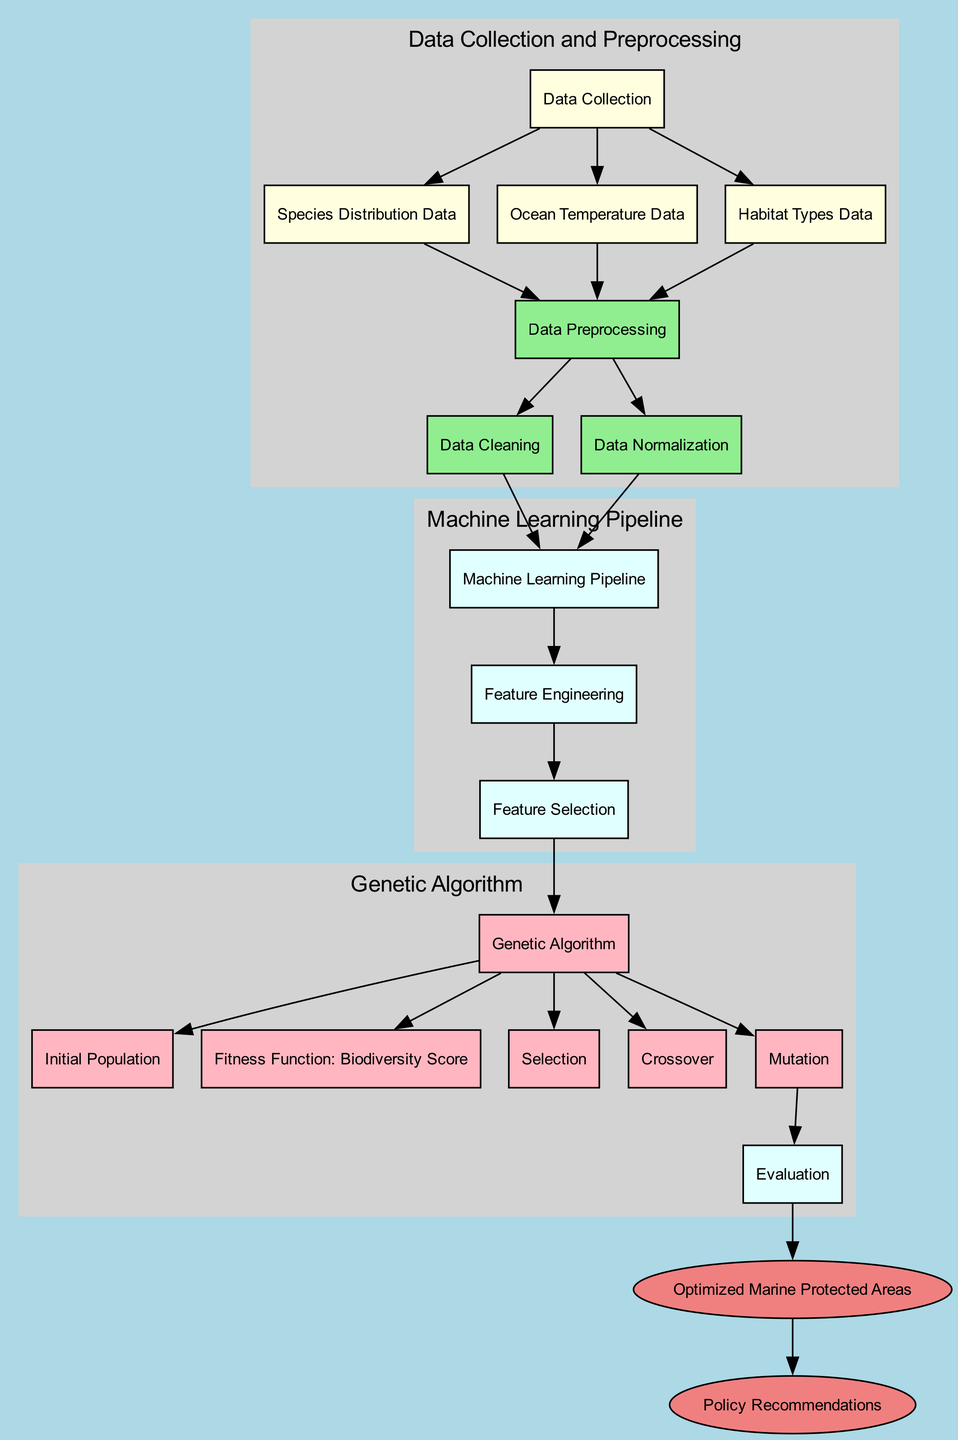What is the starting point of the diagram? The starting point of the diagram is the node labeled "Data Collection". It serves as the first step before any data processing occurs.
Answer: Data Collection How many nodes are in the diagram? The diagram contains a total of 17 nodes, each representing a different component of the marine protected areas optimization process.
Answer: 17 Which node follows the "Data Preprocessing" node? The nodes that immediately follow "Data Preprocessing" are "Cleaning" and "Normalization". Both of these processes depend on the output of data preprocessing.
Answer: Cleaning and Normalization What is the role of the "Fitness Function" node? The "Fitness Function" node is crucial in the genetic algorithm process as it evaluates the biodiversity score, guiding the optimization of marine protected areas.
Answer: Evaluate biodiversity score Which nodes are included in the genetic algorithm process? The nodes included in the genetic algorithm process are "Genetic Algorithm", "Initial Population", "Fitness Function", "Selection", "Crossover", "Mutation", and "Evaluation", making it the most complex segment of the diagram.
Answer: Genetic Algorithm, Initial Population, Fitness Function, Selection, Crossover, Mutation, Evaluation What is the endpoint of the process shown in the diagram? The endpoint of the process is the node labeled "Policy Recommendations", which relies on the results from the "Optimized Marine Protected Areas".
Answer: Policy Recommendations How does "Ocean Temperature Data" relate to "Data Preprocessing"? The "Ocean Temperature Data" feeds into the "Data Preprocessing" node, signifying that it is one of the initial data types that will undergo cleaning, normalization, and further analysis.
Answer: Feeds into Data Preprocessing What action follows the "Evaluation" node in the diagram? After the "Evaluation" node, the action that follows is the output of the "Optimized Marine Protected Areas", guiding the decision-making process in conservation strategies.
Answer: Optimized Marine Protected Areas Which subgraph does "Feature Selection" belong to? "Feature Selection" is part of the "Machine Learning Pipeline" subgraph, indicating its role in preparing the data for the genetic algorithm phase.
Answer: Machine Learning Pipeline 